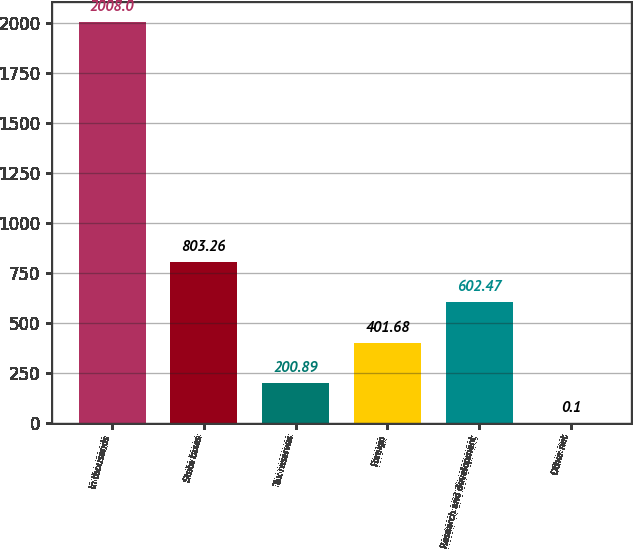<chart> <loc_0><loc_0><loc_500><loc_500><bar_chart><fcel>In thousands<fcel>State taxes<fcel>Tax reserves<fcel>Foreign<fcel>Research and development<fcel>Other net<nl><fcel>2008<fcel>803.26<fcel>200.89<fcel>401.68<fcel>602.47<fcel>0.1<nl></chart> 